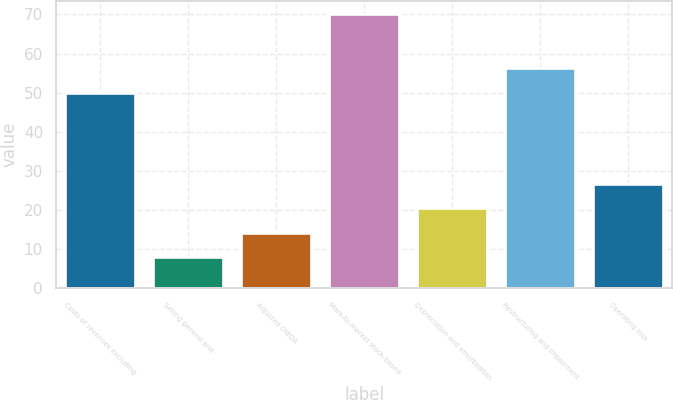Convert chart to OTSL. <chart><loc_0><loc_0><loc_500><loc_500><bar_chart><fcel>Costs of revenues excluding<fcel>Selling general and<fcel>Adjusted OIBDA<fcel>Mark-to-market stock-based<fcel>Depreciation and amortization<fcel>Restructuring and impairment<fcel>Operating loss<nl><fcel>50<fcel>8<fcel>14.2<fcel>70<fcel>20.4<fcel>56.2<fcel>26.6<nl></chart> 